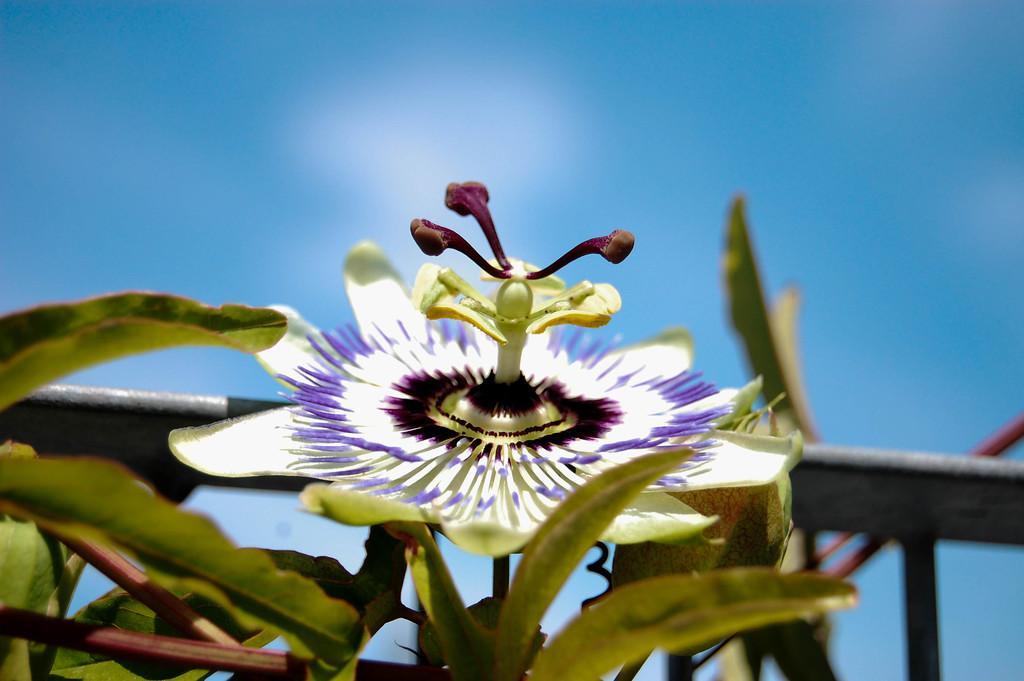Please provide a concise description of this image. This image consists of a plant along with a flower. In the background, there is a railing in black color. To the top, there is a sky. 